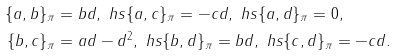<formula> <loc_0><loc_0><loc_500><loc_500>\{ a , b \} _ { \pi } & = b d , \ h s \{ a , c \} _ { \pi } = - c d , \ h s \{ a , d \} _ { \pi } = 0 , \\ \{ b , c \} _ { \pi } & = a d - d ^ { 2 } , \ h s \{ b , d \} _ { \pi } = b d , \ h s \{ c , d \} _ { \pi } = - c d .</formula> 